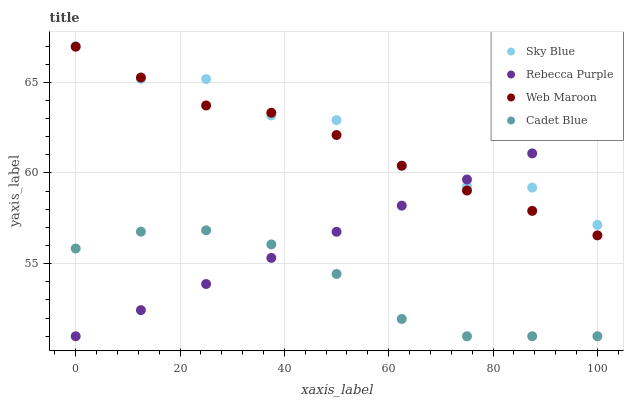Does Cadet Blue have the minimum area under the curve?
Answer yes or no. Yes. Does Sky Blue have the maximum area under the curve?
Answer yes or no. Yes. Does Web Maroon have the minimum area under the curve?
Answer yes or no. No. Does Web Maroon have the maximum area under the curve?
Answer yes or no. No. Is Rebecca Purple the smoothest?
Answer yes or no. Yes. Is Sky Blue the roughest?
Answer yes or no. Yes. Is Cadet Blue the smoothest?
Answer yes or no. No. Is Cadet Blue the roughest?
Answer yes or no. No. Does Cadet Blue have the lowest value?
Answer yes or no. Yes. Does Web Maroon have the lowest value?
Answer yes or no. No. Does Sky Blue have the highest value?
Answer yes or no. Yes. Does Web Maroon have the highest value?
Answer yes or no. No. Is Cadet Blue less than Sky Blue?
Answer yes or no. Yes. Is Web Maroon greater than Cadet Blue?
Answer yes or no. Yes. Does Rebecca Purple intersect Sky Blue?
Answer yes or no. Yes. Is Rebecca Purple less than Sky Blue?
Answer yes or no. No. Is Rebecca Purple greater than Sky Blue?
Answer yes or no. No. Does Cadet Blue intersect Sky Blue?
Answer yes or no. No. 